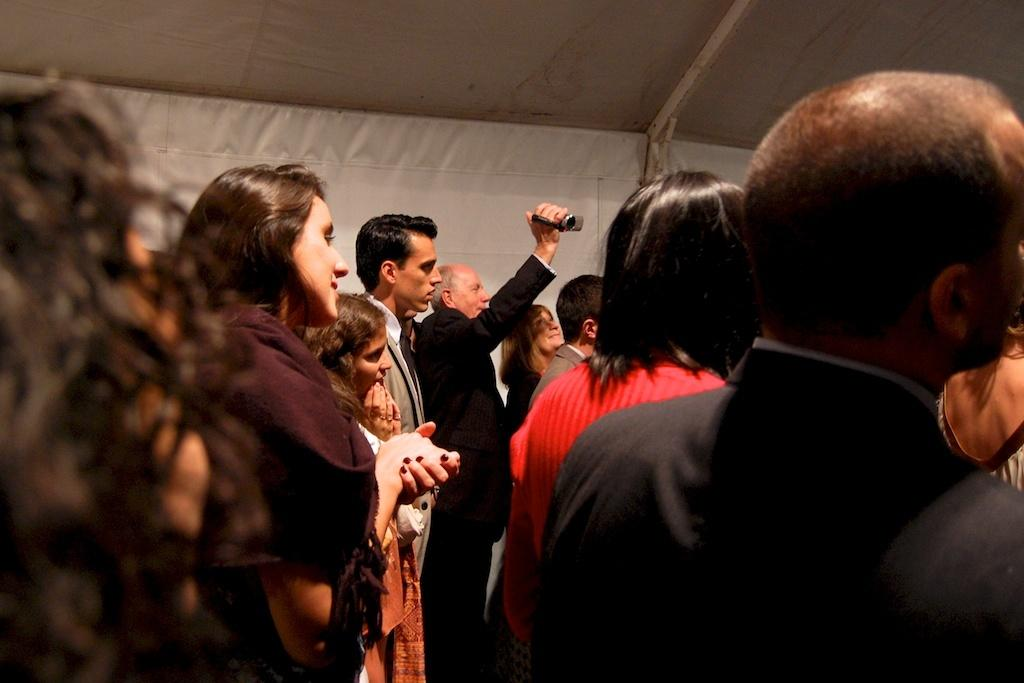What are the people in the image doing? The people in the image are standing. What object is one of the people holding? One of the people is holding a camera. What can be seen in the background of the image? There is a wall in the background of the image. What part of a building can be seen at the top of the image? There is a roof visible at the top of the image. Is there a maid in the image helping the people with their chores? There is no maid present in the image. What impulse might have caused the people to gather in the image? The image does not provide information about the people's motivations or impulses for gathering. 